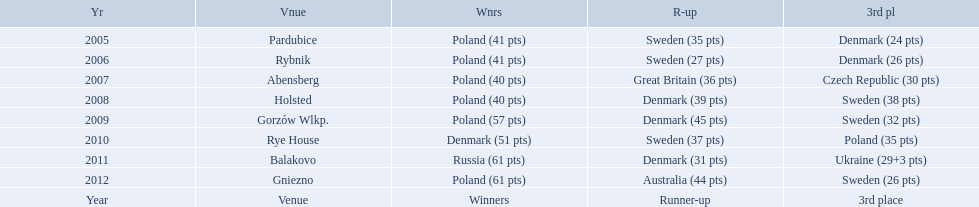After enjoying five consecutive victories at the team speedway junior world championship poland was finally unseated in what year? 2010. In that year, what teams placed first through third? Denmark (51 pts), Sweden (37 pts), Poland (35 pts). Which of those positions did poland specifically place in? 3rd place. 